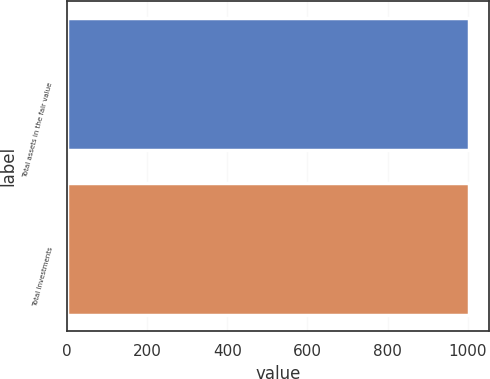Convert chart. <chart><loc_0><loc_0><loc_500><loc_500><bar_chart><fcel>Total assets in the fair value<fcel>Total Investments<nl><fcel>1002<fcel>1002.1<nl></chart> 